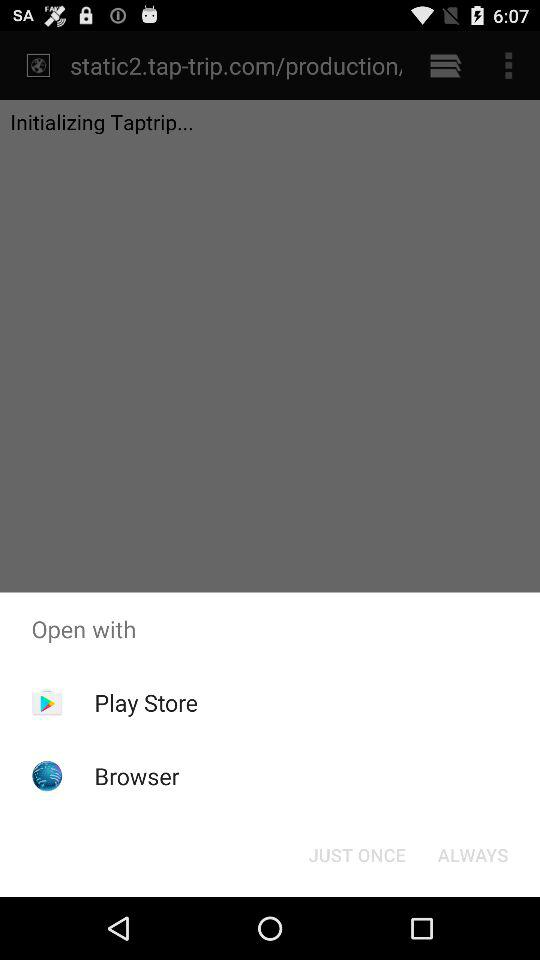Which applications can be used to open the content? The applications that can be used to open the content are "Play Store" and "Browser". 